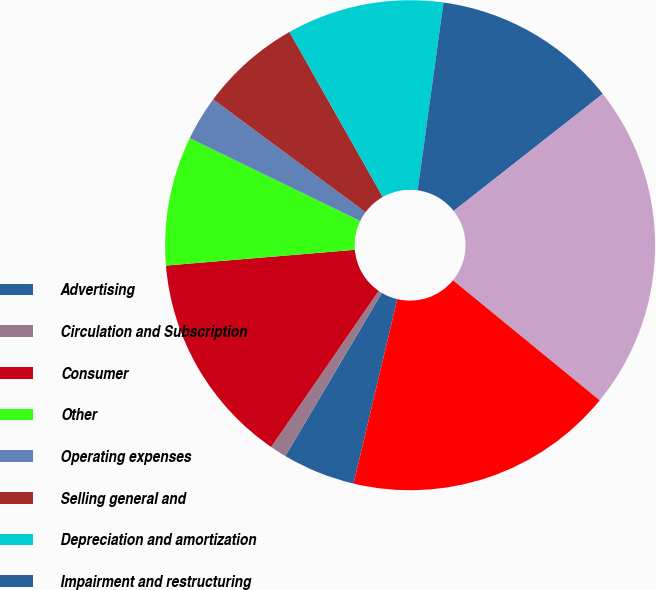<chart> <loc_0><loc_0><loc_500><loc_500><pie_chart><fcel>Advertising<fcel>Circulation and Subscription<fcel>Consumer<fcel>Other<fcel>Operating expenses<fcel>Selling general and<fcel>Depreciation and amortization<fcel>Impairment and restructuring<fcel>Equity earnings of affiliates<fcel>Interest net<nl><fcel>4.8%<fcel>1.09%<fcel>14.08%<fcel>8.52%<fcel>2.95%<fcel>6.66%<fcel>10.37%<fcel>12.23%<fcel>21.51%<fcel>17.79%<nl></chart> 